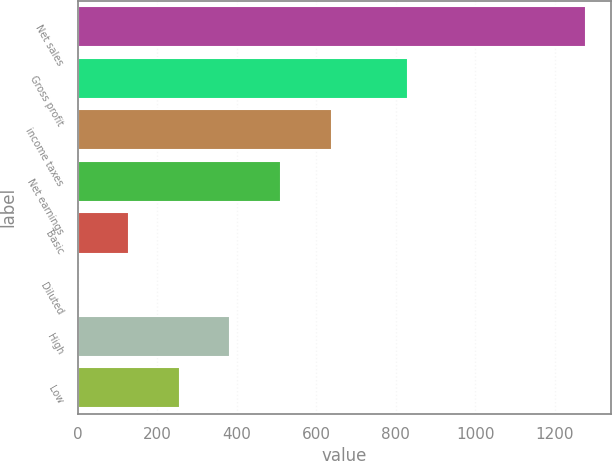<chart> <loc_0><loc_0><loc_500><loc_500><bar_chart><fcel>Net sales<fcel>Gross profit<fcel>income taxes<fcel>Net earnings<fcel>Basic<fcel>Diluted<fcel>High<fcel>Low<nl><fcel>1278.5<fcel>830.4<fcel>639.48<fcel>511.67<fcel>128.24<fcel>0.43<fcel>383.86<fcel>256.05<nl></chart> 